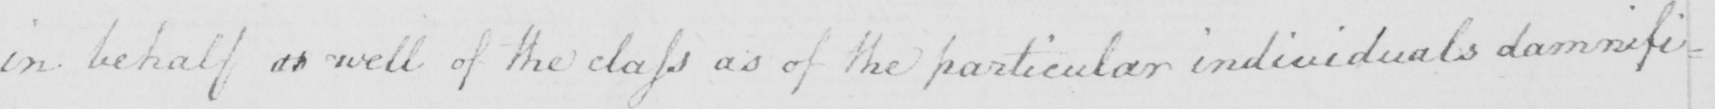Please provide the text content of this handwritten line. in behalf as well of the class as of the particular individuals damnifi= 